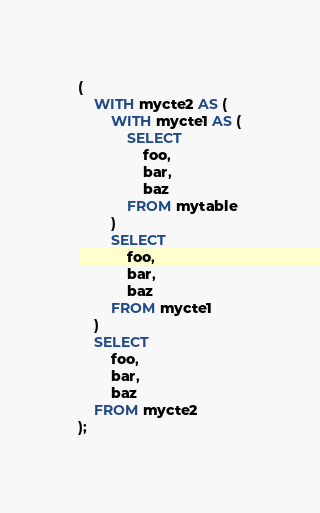Convert code to text. <code><loc_0><loc_0><loc_500><loc_500><_SQL_>(
    WITH mycte2 AS (
        WITH mycte1 AS (
            SELECT
                foo,
                bar,
                baz
            FROM mytable
        )
        SELECT
            foo,
            bar,
            baz
        FROM mycte1
    )
    SELECT
        foo,
        bar,
        baz
    FROM mycte2
);
</code> 